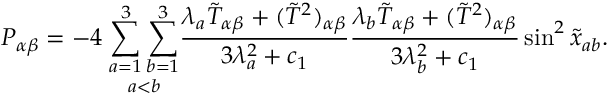Convert formula to latex. <formula><loc_0><loc_0><loc_500><loc_500>P _ { \alpha \beta } = - 4 \, \underset { a < b } { \sum _ { a = 1 } ^ { 3 } \sum _ { b = 1 } ^ { 3 } } \frac { \lambda _ { a } \tilde { T } _ { \alpha \beta } + ( \tilde { T } ^ { 2 } ) _ { \alpha \beta } } { 3 \lambda _ { a } ^ { 2 } + c _ { 1 } } \frac { \lambda _ { b } \tilde { T } _ { \alpha \beta } + ( \tilde { T } ^ { 2 } ) _ { \alpha \beta } } { 3 \lambda _ { b } ^ { 2 } + c _ { 1 } } \sin ^ { 2 } \tilde { x } _ { a b } .</formula> 